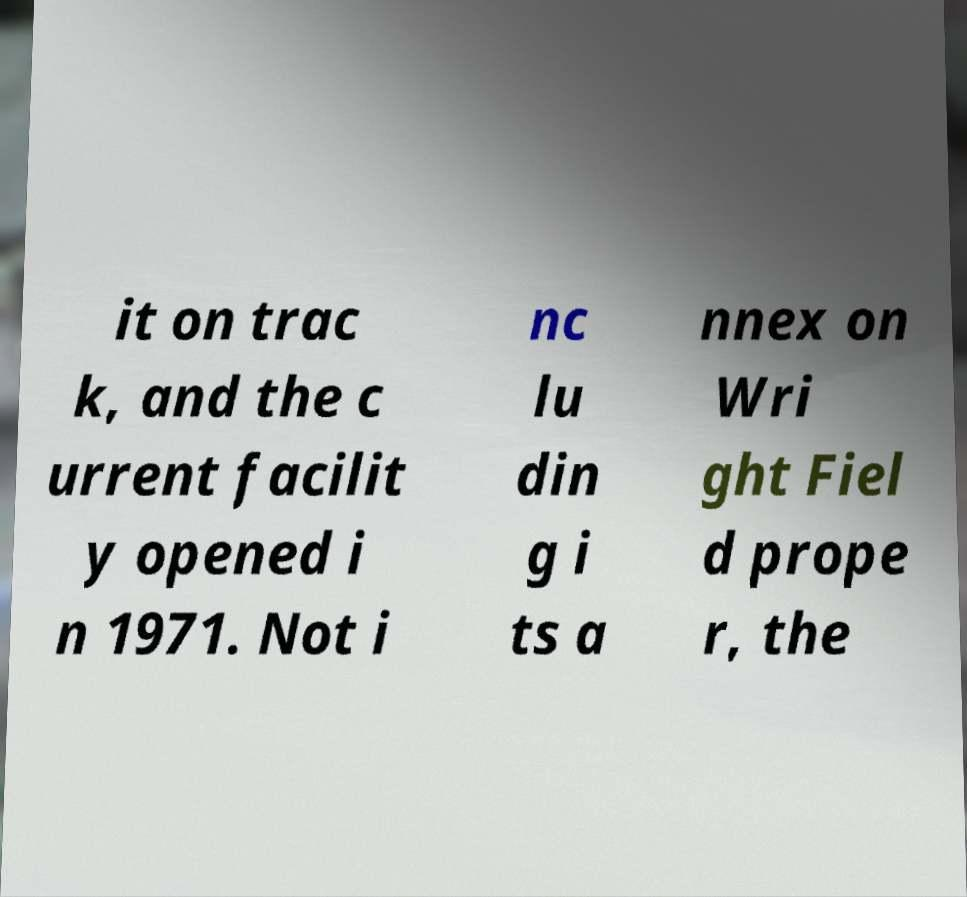Please identify and transcribe the text found in this image. it on trac k, and the c urrent facilit y opened i n 1971. Not i nc lu din g i ts a nnex on Wri ght Fiel d prope r, the 